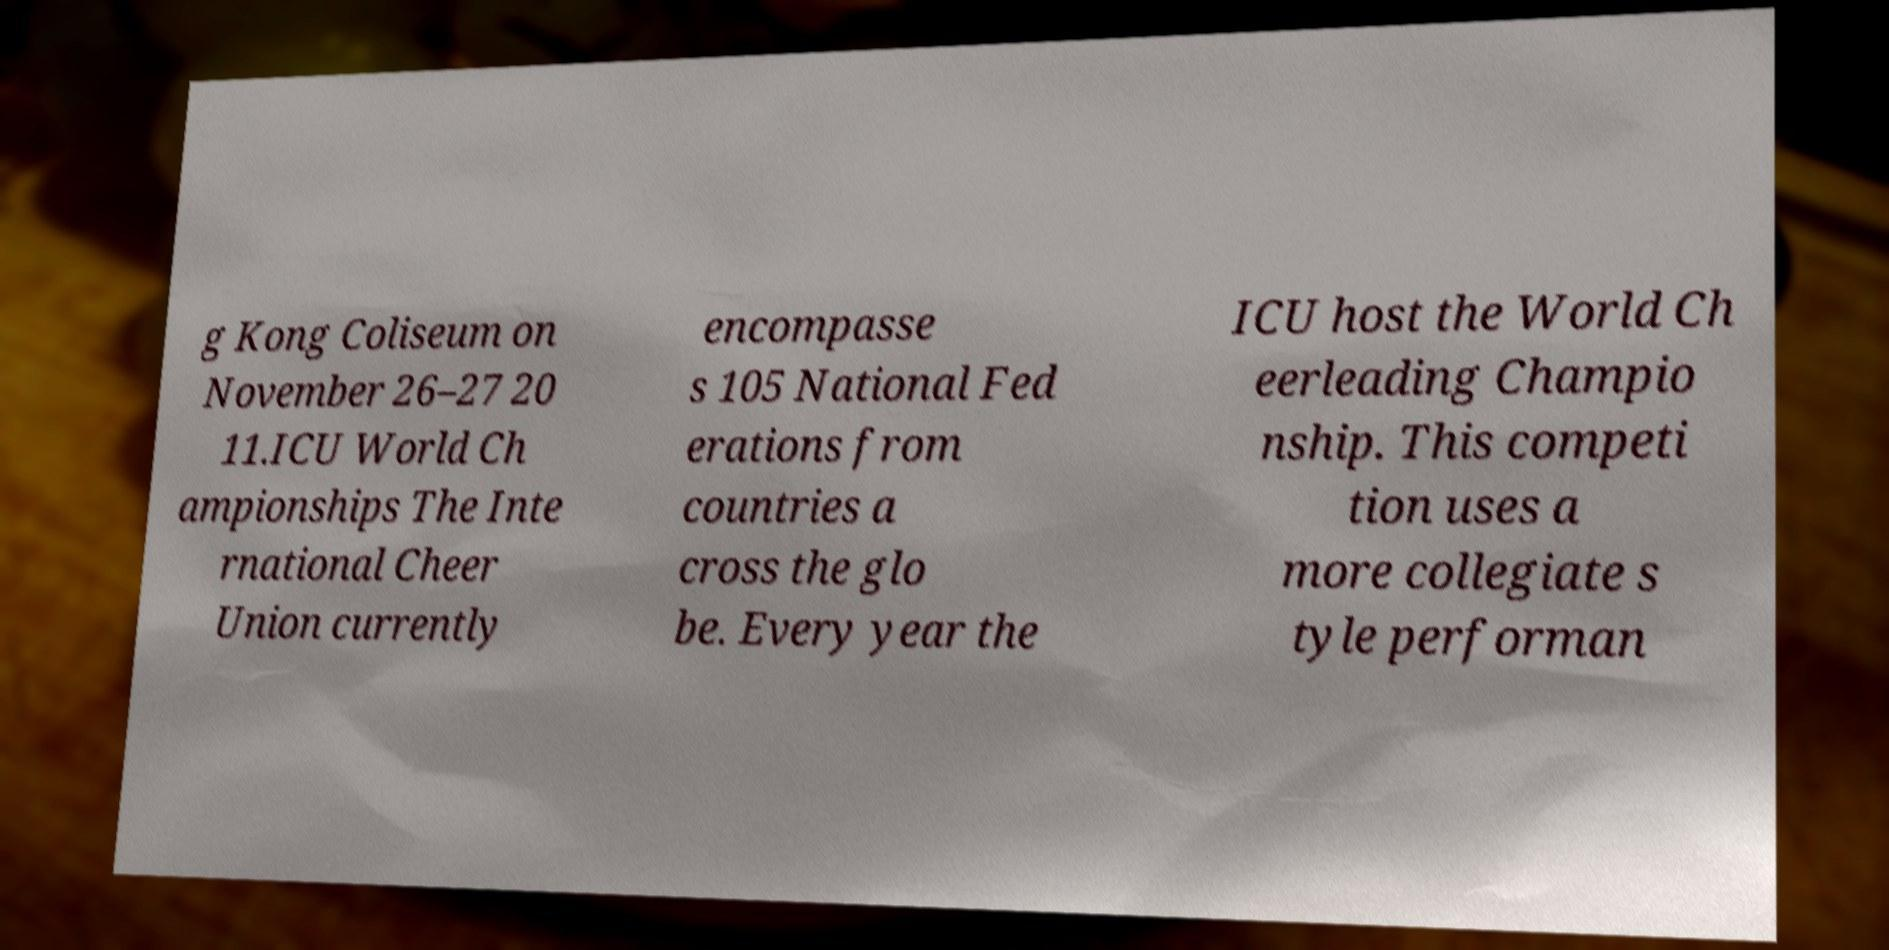Can you read and provide the text displayed in the image?This photo seems to have some interesting text. Can you extract and type it out for me? g Kong Coliseum on November 26–27 20 11.ICU World Ch ampionships The Inte rnational Cheer Union currently encompasse s 105 National Fed erations from countries a cross the glo be. Every year the ICU host the World Ch eerleading Champio nship. This competi tion uses a more collegiate s tyle performan 